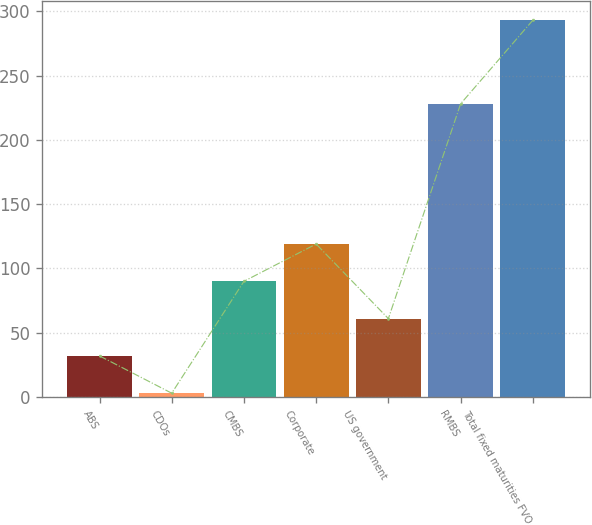Convert chart to OTSL. <chart><loc_0><loc_0><loc_500><loc_500><bar_chart><fcel>ABS<fcel>CDOs<fcel>CMBS<fcel>Corporate<fcel>US government<fcel>RMBS<fcel>Total fixed maturities FVO<nl><fcel>32<fcel>3<fcel>90<fcel>119<fcel>61<fcel>228<fcel>293<nl></chart> 